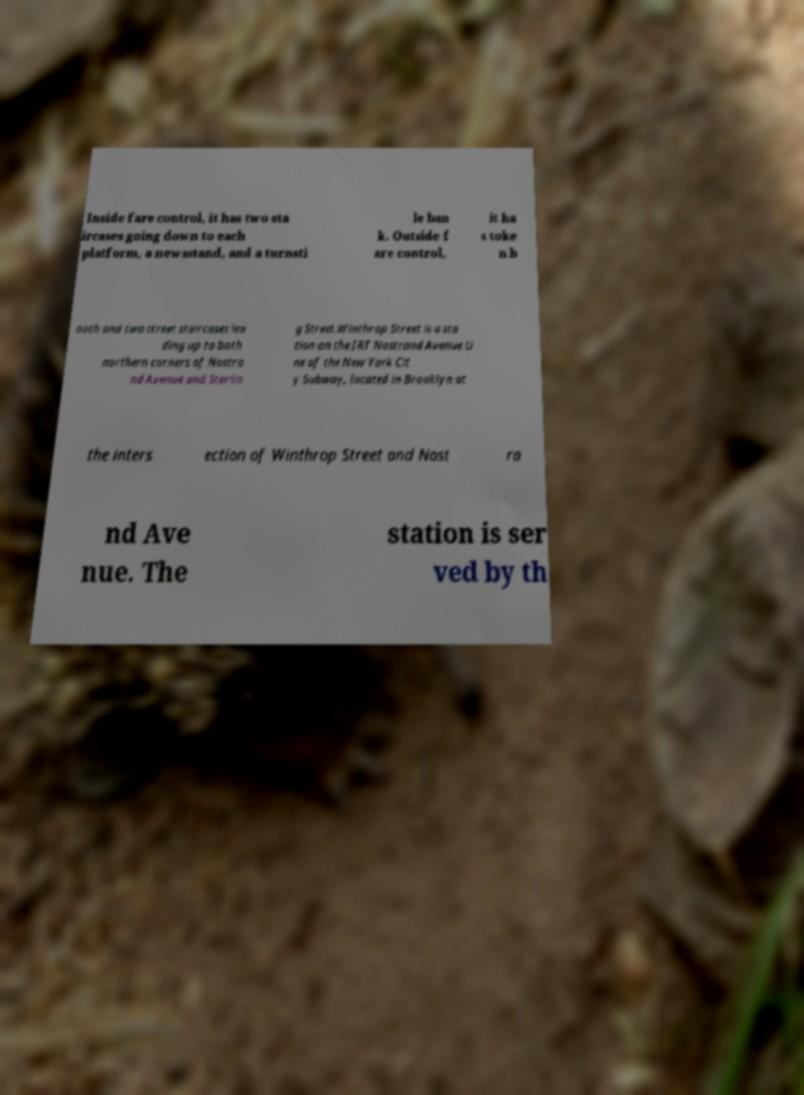There's text embedded in this image that I need extracted. Can you transcribe it verbatim? Inside fare control, it has two sta ircases going down to each platform, a newsstand, and a turnsti le ban k. Outside f are control, it ha s toke n b ooth and two street staircases lea ding up to both northern corners of Nostra nd Avenue and Sterlin g Street.Winthrop Street is a sta tion on the IRT Nostrand Avenue Li ne of the New York Cit y Subway, located in Brooklyn at the inters ection of Winthrop Street and Nost ra nd Ave nue. The station is ser ved by th 